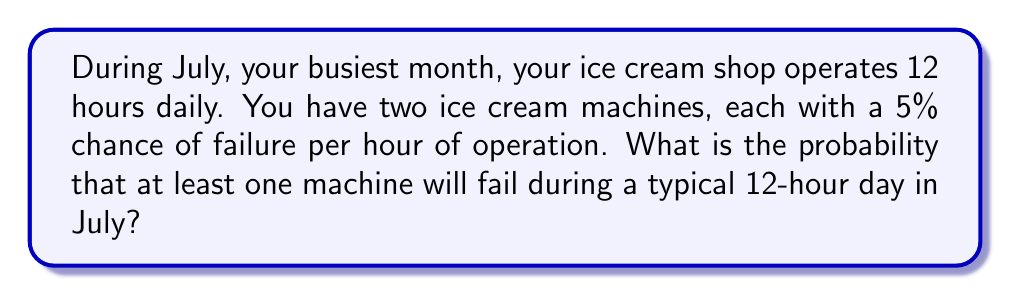Solve this math problem. Let's approach this step-by-step:

1) First, let's calculate the probability of a single machine not failing during one hour:
   $P(\text{no failure in 1 hour}) = 1 - 0.05 = 0.95$

2) For a 12-hour day, the probability of a single machine not failing is:
   $P(\text{no failure in 12 hours}) = 0.95^{12} \approx 0.5404$

3) Now, for both machines to not fail during the 12-hour period:
   $P(\text{both machines don't fail}) = 0.5404^2 \approx 0.2920$

4) Therefore, the probability of at least one machine failing is the complement of this:
   $P(\text{at least one fails}) = 1 - P(\text{both don't fail})$
   $= 1 - 0.2920 \approx 0.7080$

5) Converting to a percentage:
   $0.7080 \times 100\% = 70.80\%$

Thus, there is approximately a 70.80% chance that at least one ice cream machine will fail during a typical 12-hour day in July.
Answer: 70.80% 